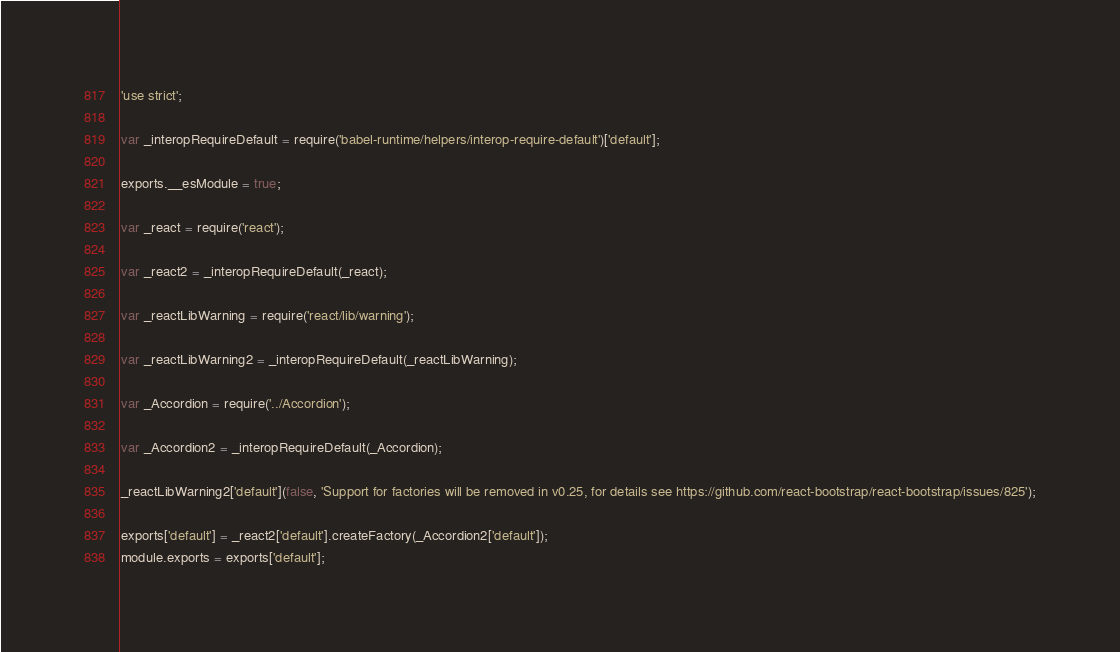Convert code to text. <code><loc_0><loc_0><loc_500><loc_500><_JavaScript_>'use strict';

var _interopRequireDefault = require('babel-runtime/helpers/interop-require-default')['default'];

exports.__esModule = true;

var _react = require('react');

var _react2 = _interopRequireDefault(_react);

var _reactLibWarning = require('react/lib/warning');

var _reactLibWarning2 = _interopRequireDefault(_reactLibWarning);

var _Accordion = require('../Accordion');

var _Accordion2 = _interopRequireDefault(_Accordion);

_reactLibWarning2['default'](false, 'Support for factories will be removed in v0.25, for details see https://github.com/react-bootstrap/react-bootstrap/issues/825');

exports['default'] = _react2['default'].createFactory(_Accordion2['default']);
module.exports = exports['default'];</code> 